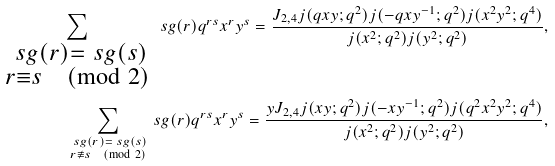Convert formula to latex. <formula><loc_0><loc_0><loc_500><loc_500>\sum _ { \substack { \ s g ( r ) = \ s g ( s ) \\ r \equiv s \pmod { 2 } } } \ s g ( r ) q ^ { r s } x ^ { r } y ^ { s } = \frac { J _ { 2 , 4 } j ( q x y ; q ^ { 2 } ) j ( - q x y ^ { - 1 } ; q ^ { 2 } ) j ( x ^ { 2 } y ^ { 2 } ; q ^ { 4 } ) } { j ( x ^ { 2 } ; q ^ { 2 } ) j ( y ^ { 2 } ; q ^ { 2 } ) } , \\ \sum _ { \substack { \ s g ( r ) = \ s g ( s ) \\ r \not \equiv s \pmod { 2 } } } \ s g ( r ) q ^ { r s } x ^ { r } y ^ { s } = \frac { y J _ { 2 , 4 } j ( x y ; q ^ { 2 } ) j ( - x y ^ { - 1 } ; q ^ { 2 } ) j ( q ^ { 2 } x ^ { 2 } y ^ { 2 } ; q ^ { 4 } ) } { j ( x ^ { 2 } ; q ^ { 2 } ) j ( y ^ { 2 } ; q ^ { 2 } ) } ,</formula> 